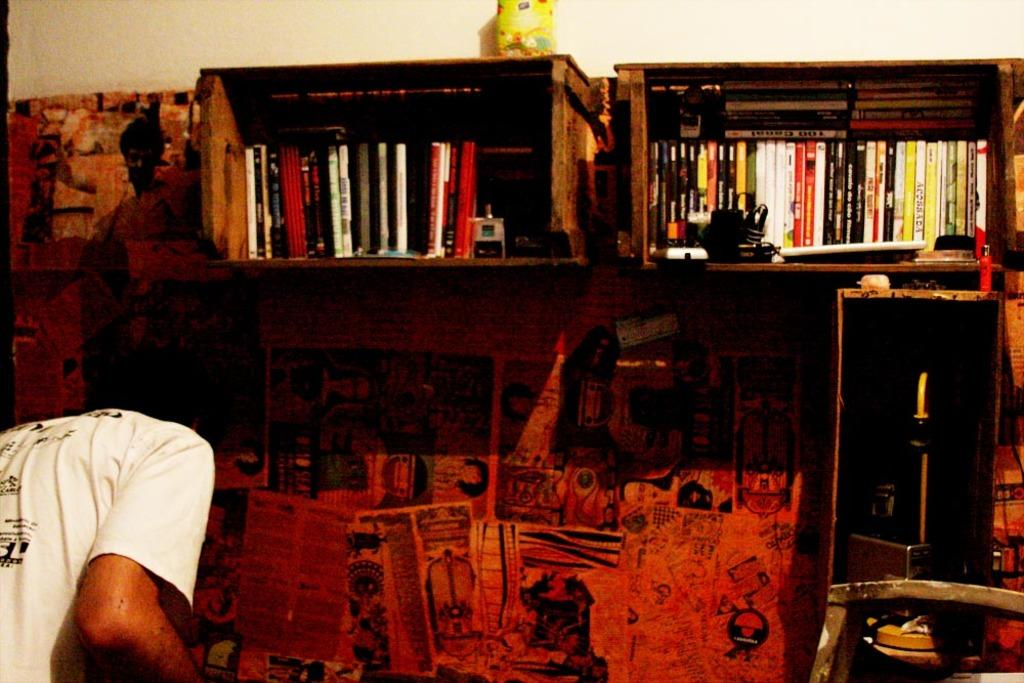Who or what is present in the image? There is a person in the image. What can be seen on the wall in the image? There are advertisements on the wall in the image. What objects are visible in the image that can be used for controlling electronic devices? There are remotes visible in the image. What type of items can be found arranged in cupboards in the image? There are books arranged in cupboards in the image. Where is the throne located in the image? There is no throne present in the image. What type of maid is shown in the image? There is no maid present in the image. 